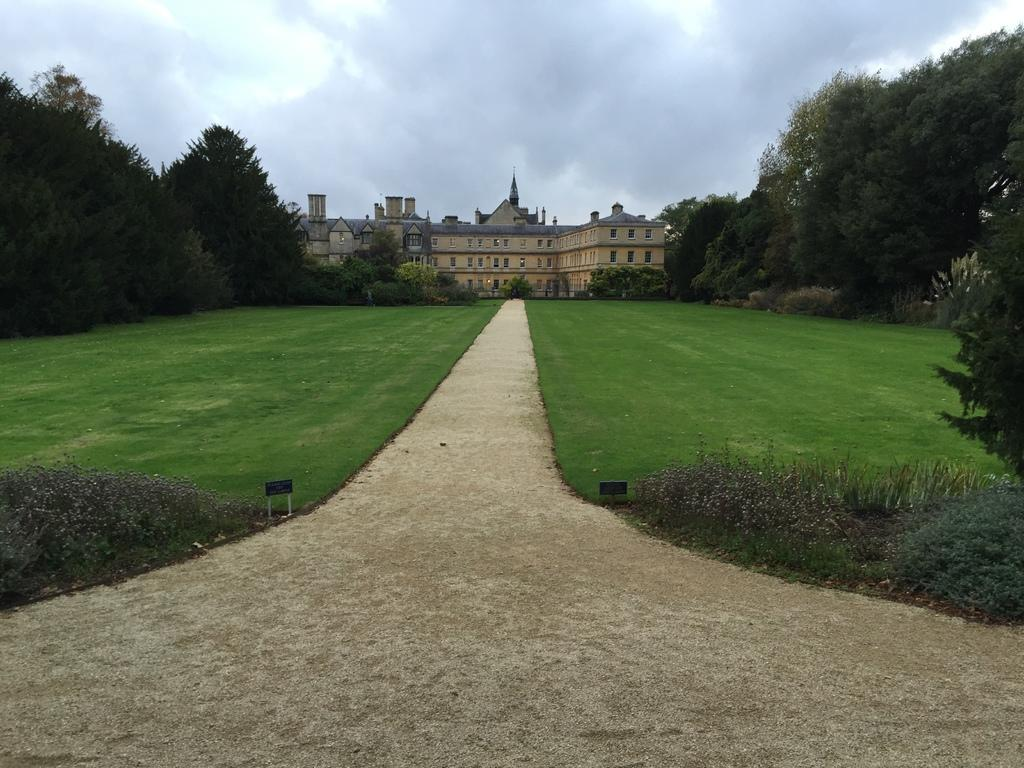What type of path is visible in the image? There is a walking path in the image. Where is the walking path located in relation to the building? The walking path is in front of a building. What type of vegetation is present in the image? Green grass is present in the image. What else can be seen in the image besides the walking path and building? Trees are visible in the image. How would you describe the weather based on the appearance of the sky in the image? The sky appears gloomy in the image. What type of meal is being prepared in the image? There is no meal being prepared in the image; it features a walking path, a building, green grass, trees, and a gloomy sky. 